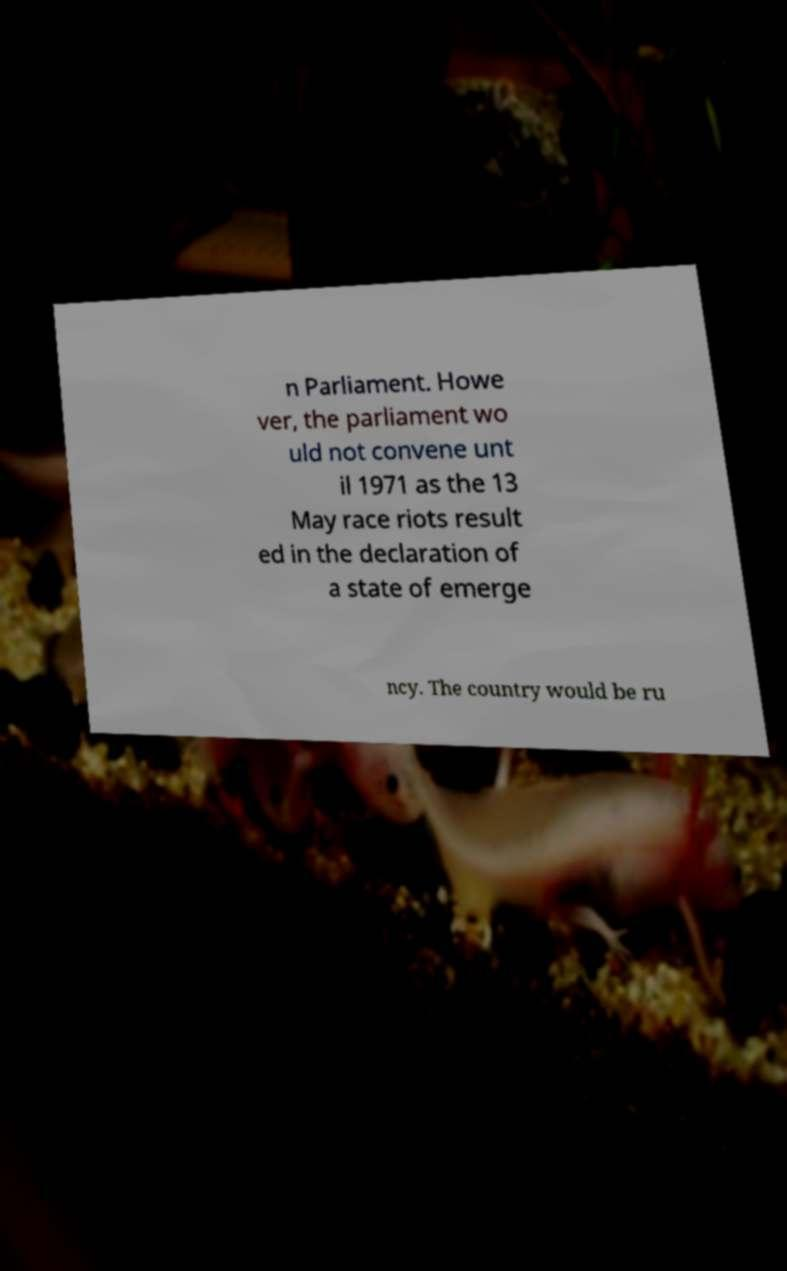There's text embedded in this image that I need extracted. Can you transcribe it verbatim? n Parliament. Howe ver, the parliament wo uld not convene unt il 1971 as the 13 May race riots result ed in the declaration of a state of emerge ncy. The country would be ru 